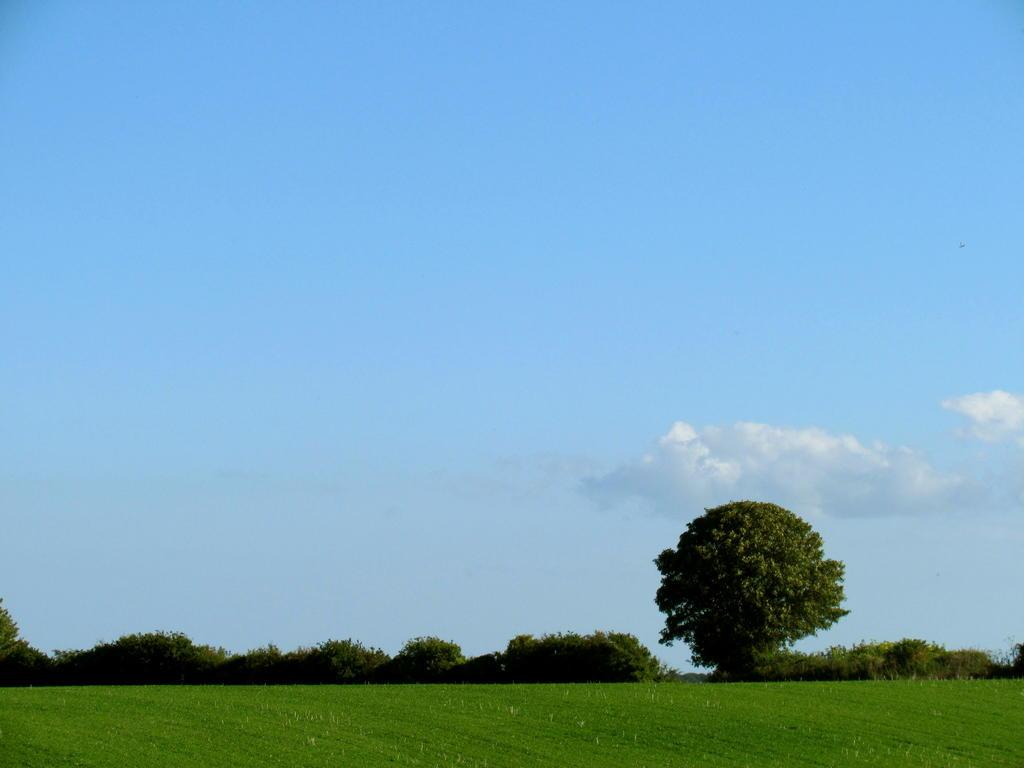What type of natural environment is visible at the bottom side of the image? There is greenery at the bottom side of the image. What part of the natural environment is visible at the top side of the image? There is sky at the top side of the image. How many people are present in the crowd at the bottom side of the image? There is no crowd present in the image; it features greenery at the bottom side. What type of cast can be seen in the image? There is no cast present in the image; it only features greenery and sky. 